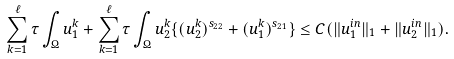Convert formula to latex. <formula><loc_0><loc_0><loc_500><loc_500>\sum _ { k = 1 } ^ { \ell } \tau \int _ { \Omega } u _ { 1 } ^ { k } + \sum _ { k = 1 } ^ { \ell } \tau \int _ { \Omega } u _ { 2 } ^ { k } \{ ( u _ { 2 } ^ { k } ) ^ { s _ { 2 2 } } + ( u _ { 1 } ^ { k } ) ^ { s _ { 2 1 } } \} \leq C ( \| u _ { 1 } ^ { i n } \| _ { 1 } + \| u _ { 2 } ^ { i n } \| _ { 1 } ) .</formula> 